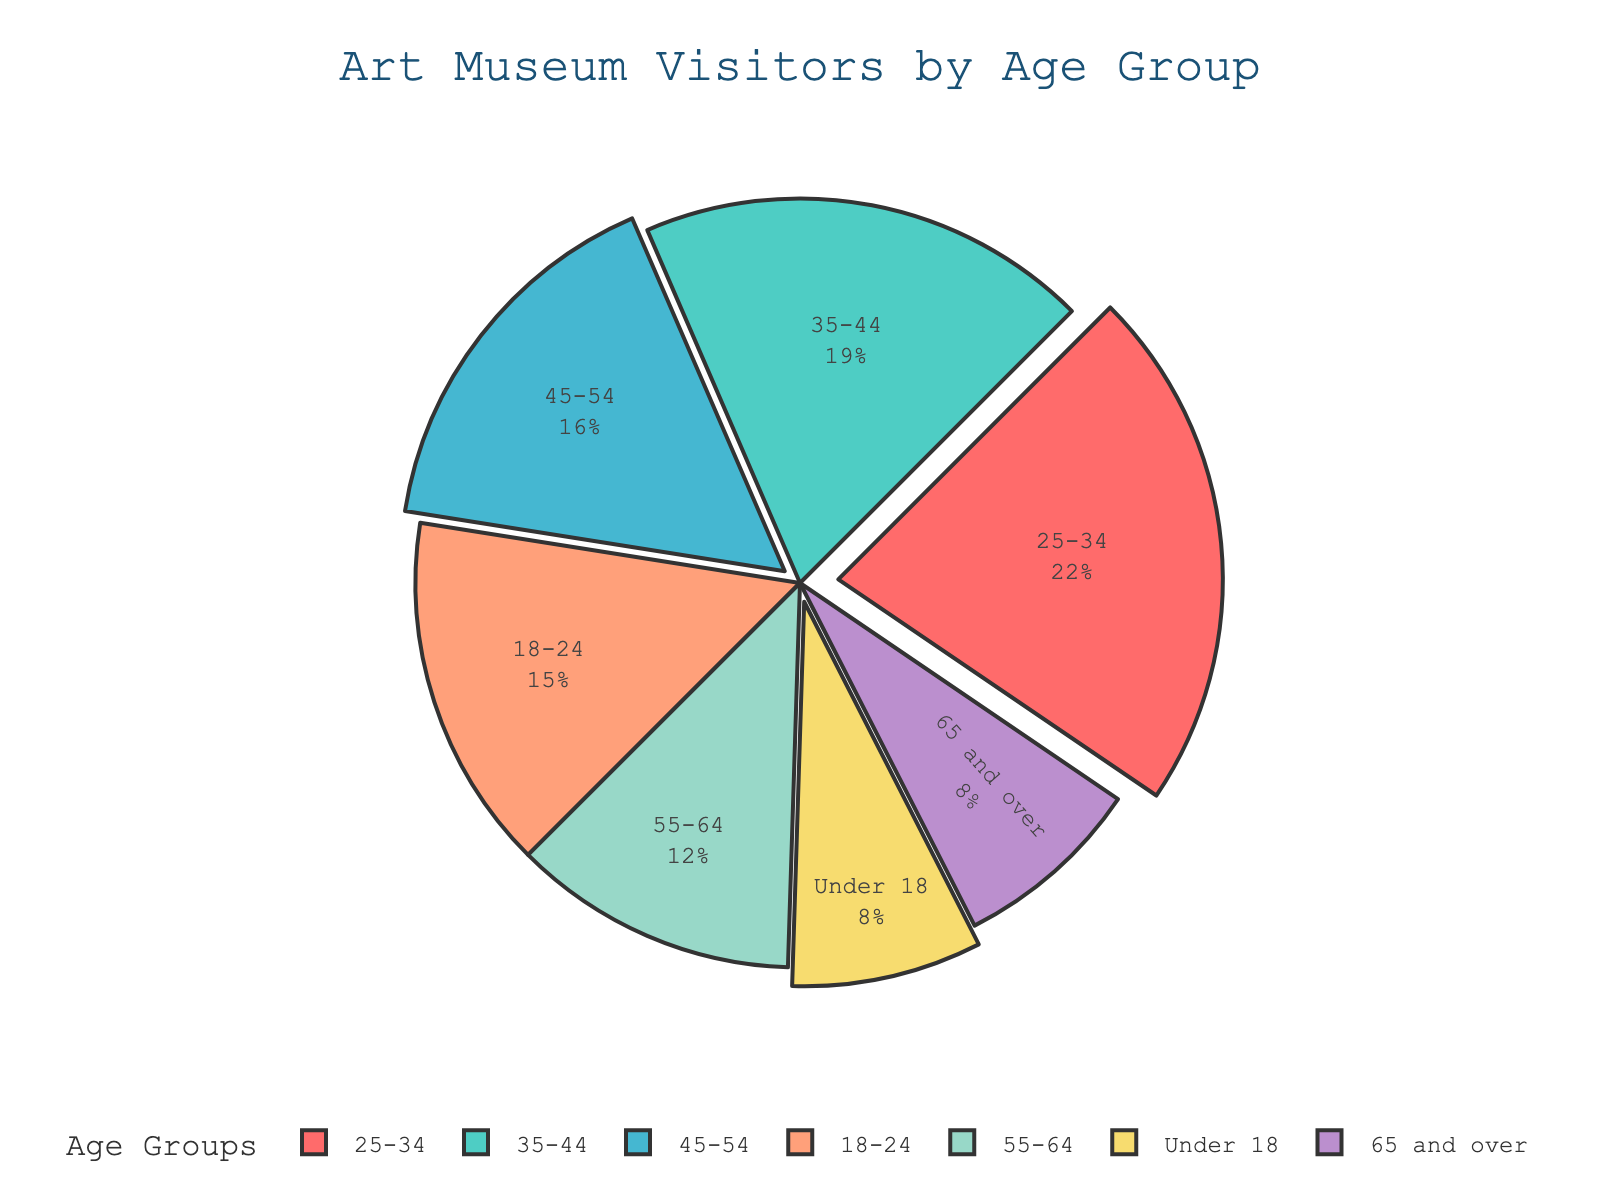What percentage of art museum visitors are aged 25-34? The figure shows a pie chart where each section's label includes its percentage. Find the one labeled '25-34' and refer to its percentage value.
Answer: 22% Which age group has the smallest percentage of visitors? Look at the pie chart and identify the age group with the smallest section, which will also have the smallest percentage label.
Answer: Under 18 and 65 and over What is the total percentage of visitors aged under 18 and 65 and over? Add the percentages of the 'Under 18' and '65 and over' age groups: 8% + 8% = 16%
Answer: 16% How much greater is the percentage of visitors aged 35-44 compared to those aged 55-64? Subtract the percentage of the '55-64' age group from the '35-44' age group: 19% - 12% = 7%
Answer: 7% Which age group has a higher percentage of visitors: 45-54 or 18-24? Compare the percentage values of the '45-54' age group and the '18-24' age group.
Answer: 45-54 What percentage of visitors are between the ages of 18 and 34? Add the percentages of the '18-24' and '25-34' age groups: 15% + 22% = 37%
Answer: 37% Which age group does the light blue section represent? Identify the section of the pie chart that is light blue and look at its label to find the corresponding age group.
Answer: 25-34 By what percentage does the largest group exceed the smallest group? Identify the percentages of the largest and smallest groups, then subtract the smallest from the largest: 22% (largest '25-34') - 8% (smallest 'Under 18' and '65 and over') = 14%
Answer: 14% Which age groups contribute to over half of the visitors combined? Add the percentages of consecutive age groups until the total exceeds 50%. The combined percentages of the '18-24', '25-34', and '35-44' age groups are 15% + 22% + 19% = 56%
Answer: 18-24, 25-34, and 35-44 What is the combined percentage of visitors aged 45 and older? Add the percentages of the age groups '45-54', '55-64', and '65 and over': 16% + 12% + 8% = 36%
Answer: 36% 